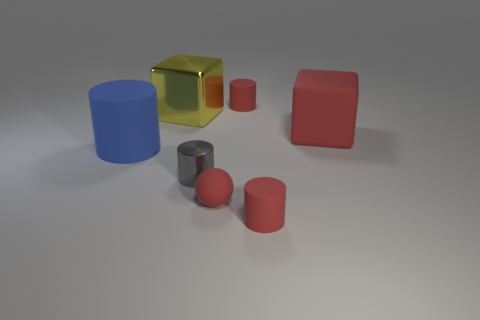What number of tiny cylinders are the same color as the small ball?
Your answer should be very brief. 2. Does the small matte sphere have the same color as the rubber cube?
Provide a succinct answer. Yes. How many other objects are there of the same color as the sphere?
Your response must be concise. 3. Is the number of tiny shiny objects that are on the left side of the large yellow metallic block less than the number of tiny red metal blocks?
Your answer should be very brief. No. Is there a tiny blue ball that has the same material as the large yellow thing?
Provide a succinct answer. No. There is a gray cylinder that is the same size as the matte ball; what is its material?
Provide a succinct answer. Metal. Is the number of small matte things that are left of the tiny matte sphere less than the number of red spheres that are behind the large yellow block?
Make the answer very short. No. What shape is the large object that is both on the right side of the large blue rubber cylinder and left of the gray thing?
Provide a succinct answer. Cube. What number of small rubber things have the same shape as the big yellow metal thing?
Keep it short and to the point. 0. There is a yellow thing that is made of the same material as the gray thing; what is its size?
Offer a very short reply. Large. 